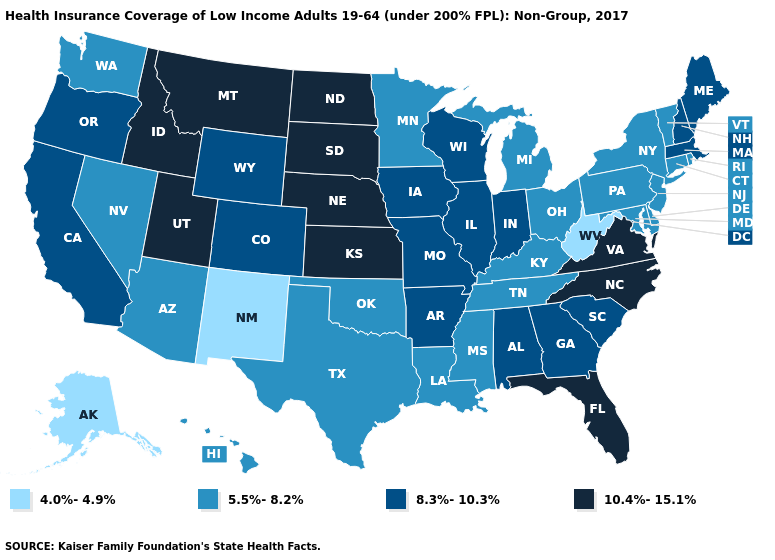What is the value of Wisconsin?
Short answer required. 8.3%-10.3%. Name the states that have a value in the range 10.4%-15.1%?
Write a very short answer. Florida, Idaho, Kansas, Montana, Nebraska, North Carolina, North Dakota, South Dakota, Utah, Virginia. Among the states that border California , does Oregon have the highest value?
Quick response, please. Yes. What is the value of Utah?
Be succinct. 10.4%-15.1%. What is the value of New York?
Write a very short answer. 5.5%-8.2%. What is the value of Pennsylvania?
Write a very short answer. 5.5%-8.2%. How many symbols are there in the legend?
Keep it brief. 4. Which states have the lowest value in the USA?
Keep it brief. Alaska, New Mexico, West Virginia. Does North Dakota have the highest value in the USA?
Answer briefly. Yes. Does Connecticut have a higher value than Alaska?
Concise answer only. Yes. Name the states that have a value in the range 10.4%-15.1%?
Short answer required. Florida, Idaho, Kansas, Montana, Nebraska, North Carolina, North Dakota, South Dakota, Utah, Virginia. Name the states that have a value in the range 4.0%-4.9%?
Concise answer only. Alaska, New Mexico, West Virginia. Does Montana have the highest value in the USA?
Concise answer only. Yes. Name the states that have a value in the range 8.3%-10.3%?
Short answer required. Alabama, Arkansas, California, Colorado, Georgia, Illinois, Indiana, Iowa, Maine, Massachusetts, Missouri, New Hampshire, Oregon, South Carolina, Wisconsin, Wyoming. What is the highest value in the USA?
Write a very short answer. 10.4%-15.1%. 